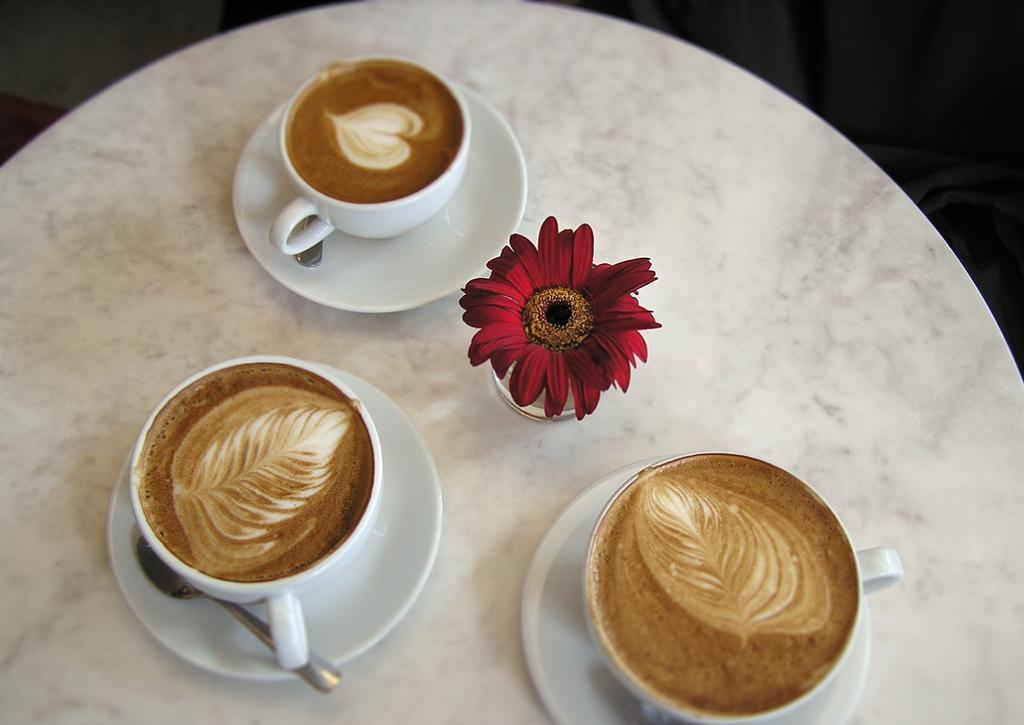Please provide a concise description of this image. On a white table we can see cups, saucers and spoons. Here we can see coffee. We can see a glass and red flower. 